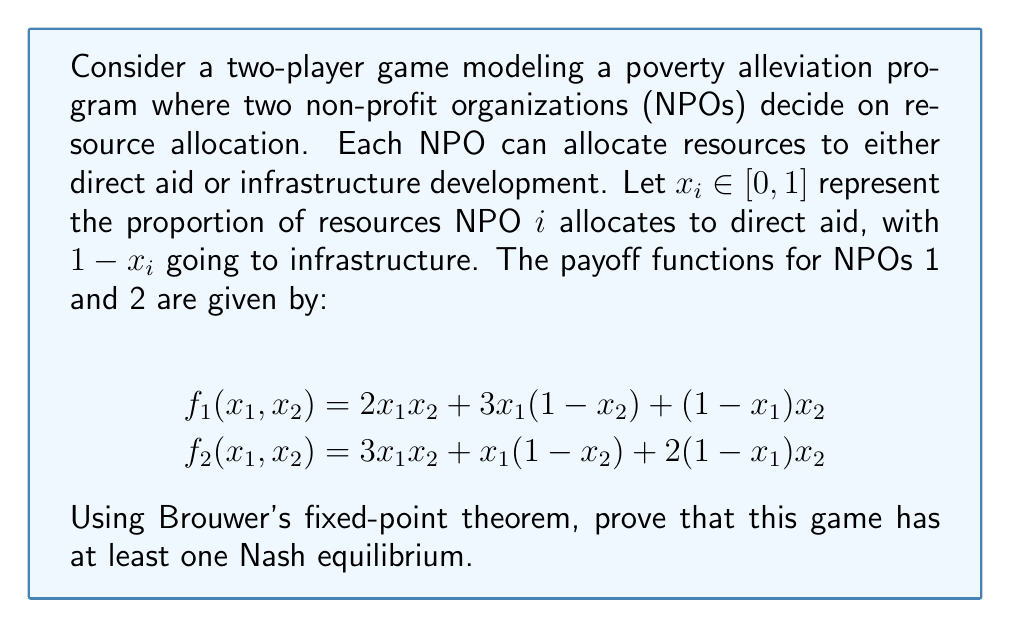Give your solution to this math problem. To prove the existence of a Nash equilibrium using Brouwer's fixed-point theorem, we'll follow these steps:

1) First, we need to define best response functions for each player. The best response function $BR_i(x_{-i})$ gives the optimal strategy for player $i$ given the other player's strategy $x_{-i}$.

2) For NPO 1:
   $$BR_1(x_2) = \arg\max_{x_1 \in [0,1]} f_1(x_1, x_2)$$
   $$\frac{\partial f_1}{\partial x_1} = 2x_2 + 3(1-x_2) - x_2 = 3 - x_2$$
   
   This is always positive for $x_2 \in [0,1]$, so $BR_1(x_2) = 1$ for all $x_2$.

3) For NPO 2:
   $$BR_2(x_1) = \arg\max_{x_2 \in [0,1]} f_2(x_1, x_2)$$
   $$\frac{\partial f_2}{\partial x_2} = 3x_1 - x_1 + 2(1-x_1) = 2 - x_1$$
   
   This is always positive for $x_1 \in [0,1]$, so $BR_2(x_1) = 1$ for all $x_1$.

4) Now, we can define a combined best response function:
   $$BR(x_1, x_2) = (BR_1(x_2), BR_2(x_1)) = (1, 1)$$

5) This function $BR: [0,1]^2 \to [0,1]^2$ is continuous (in fact, constant) and maps the compact, convex set $[0,1]^2$ to itself.

6) By Brouwer's fixed-point theorem, there exists a fixed point $(x_1^*, x_2^*)$ such that:
   $$(x_1^*, x_2^*) = BR(x_1^*, x_2^*) = (1, 1)$$

7) This fixed point $(1, 1)$ is a Nash equilibrium because each player's strategy is a best response to the other's strategy.

Therefore, we have proved that this game has at least one Nash equilibrium, namely $(x_1^*, x_2^*) = (1, 1)$.
Answer: The game has at least one Nash equilibrium: $(x_1^*, x_2^*) = (1, 1)$. This means both NPOs allocate all their resources to direct aid in equilibrium. 